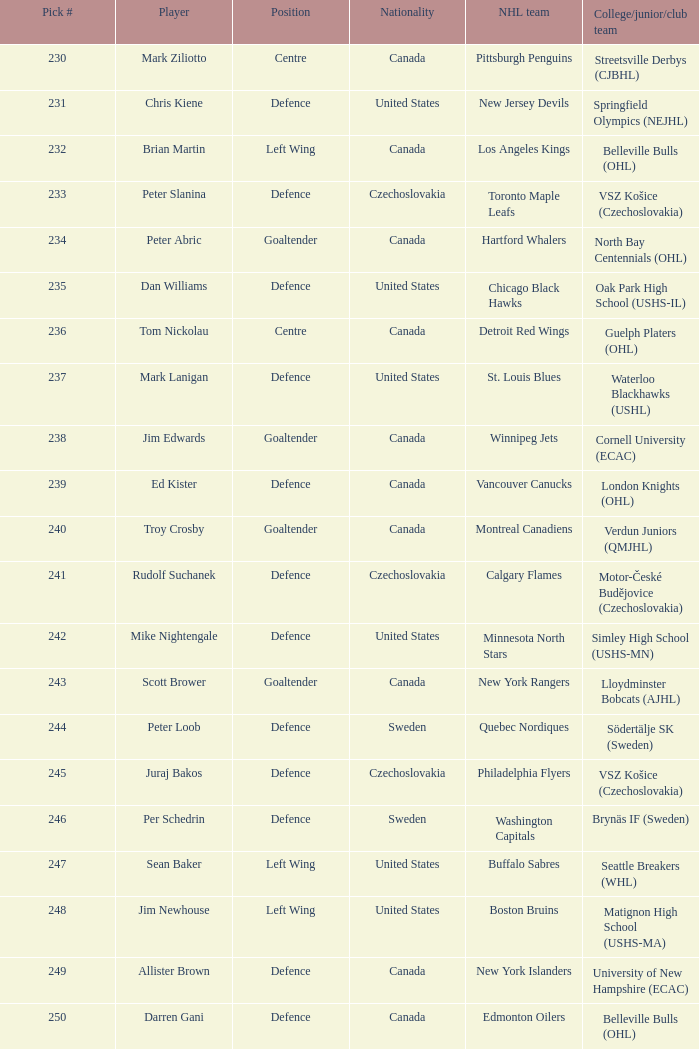Which draft number did the new jersey devils get? 231.0. 